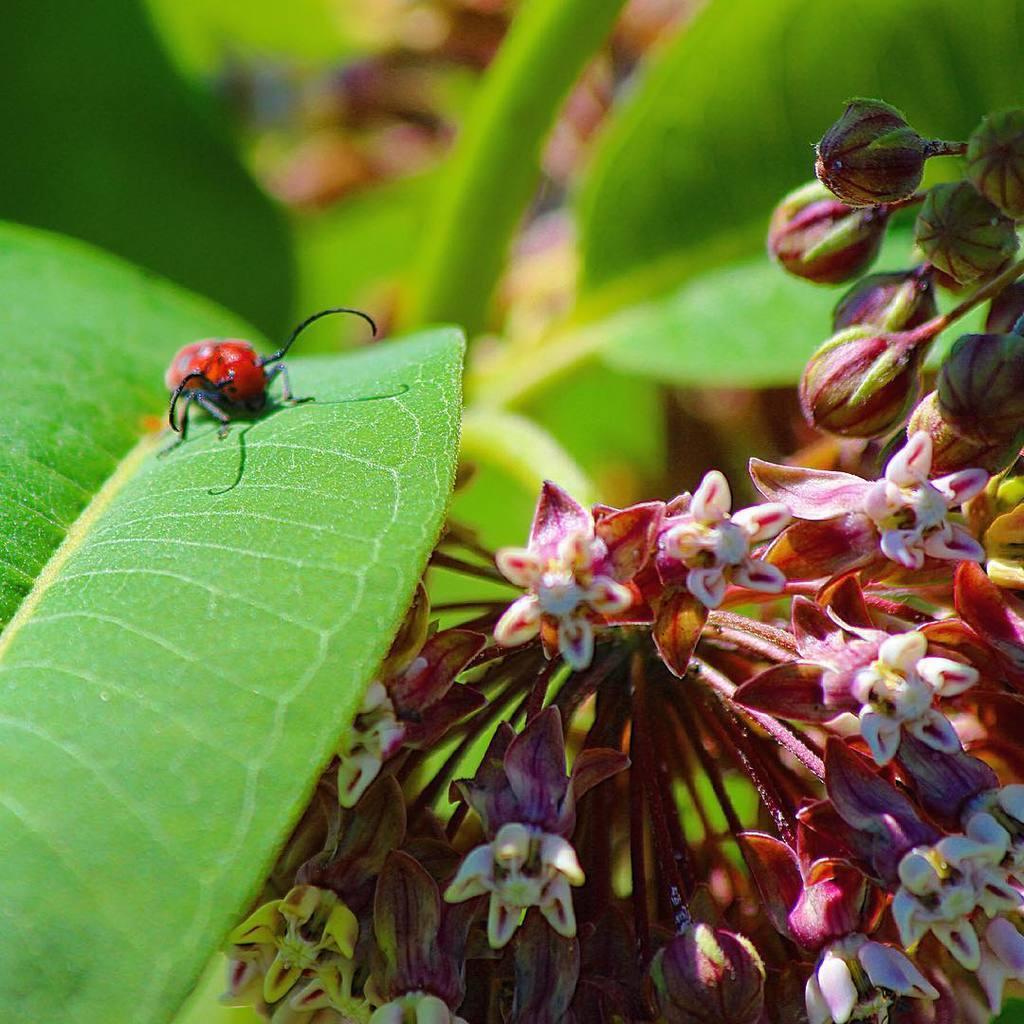Describe this image in one or two sentences. In the image there is an insect on a leaf and beside the leaf there are flowers. 